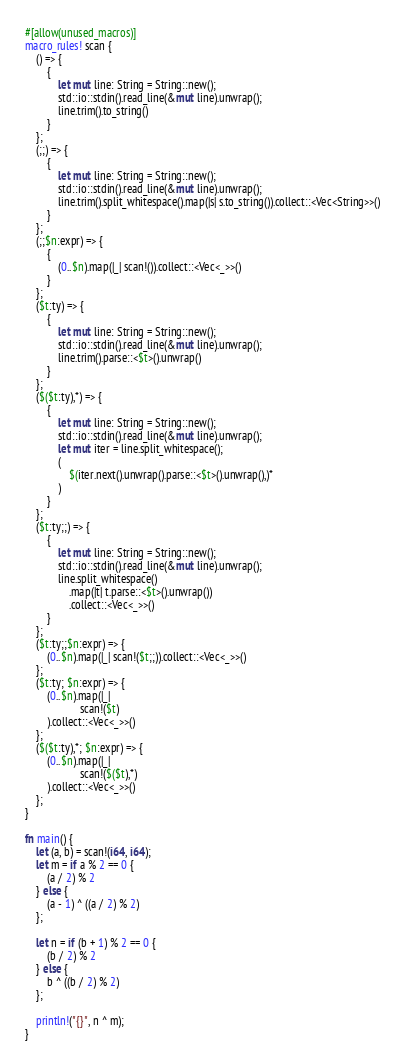Convert code to text. <code><loc_0><loc_0><loc_500><loc_500><_Rust_>#[allow(unused_macros)]
macro_rules! scan {
    () => {
        {
            let mut line: String = String::new();
            std::io::stdin().read_line(&mut line).unwrap();
            line.trim().to_string()
        }
    };
    (;;) => {
        {
            let mut line: String = String::new();
            std::io::stdin().read_line(&mut line).unwrap();
            line.trim().split_whitespace().map(|s| s.to_string()).collect::<Vec<String>>()
        }
    };
    (;;$n:expr) => {
        {
            (0..$n).map(|_| scan!()).collect::<Vec<_>>()
        }
    };
    ($t:ty) => {
        {
            let mut line: String = String::new();
            std::io::stdin().read_line(&mut line).unwrap();
            line.trim().parse::<$t>().unwrap()
        }
    };
    ($($t:ty),*) => {
        {
            let mut line: String = String::new();
            std::io::stdin().read_line(&mut line).unwrap();
            let mut iter = line.split_whitespace();
            (
                $(iter.next().unwrap().parse::<$t>().unwrap(),)*
            )
        }
    };
    ($t:ty;;) => {
        {
            let mut line: String = String::new();
            std::io::stdin().read_line(&mut line).unwrap();
            line.split_whitespace()
                .map(|t| t.parse::<$t>().unwrap())
                .collect::<Vec<_>>()
        }
    };
    ($t:ty;;$n:expr) => {
        (0..$n).map(|_| scan!($t;;)).collect::<Vec<_>>()
    };
    ($t:ty; $n:expr) => {
        (0..$n).map(|_|
                    scan!($t)
        ).collect::<Vec<_>>()
    };
    ($($t:ty),*; $n:expr) => {
        (0..$n).map(|_|
                    scan!($($t),*)
        ).collect::<Vec<_>>()
    };
}

fn main() {
    let (a, b) = scan!(i64, i64);
    let m = if a % 2 == 0 {
        (a / 2) % 2
    } else {
        (a - 1) ^ ((a / 2) % 2)
    };

    let n = if (b + 1) % 2 == 0 {
        (b / 2) % 2
    } else {
        b ^ ((b / 2) % 2)
    };

    println!("{}", n ^ m);
}
</code> 